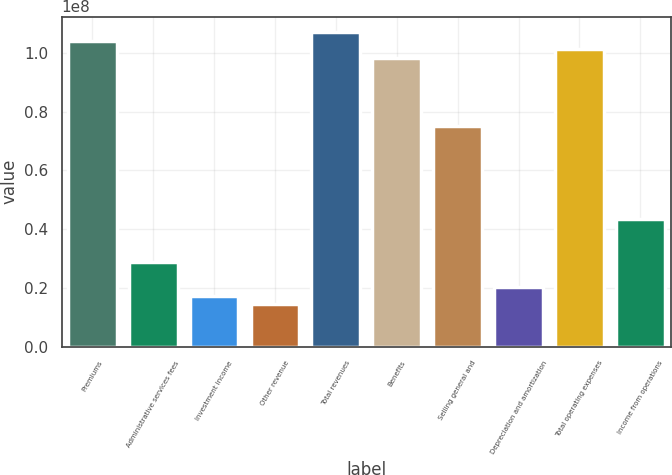Convert chart to OTSL. <chart><loc_0><loc_0><loc_500><loc_500><bar_chart><fcel>Premiums<fcel>Administrative services fees<fcel>Investment income<fcel>Other revenue<fcel>Total revenues<fcel>Benefits<fcel>Selling general and<fcel>Depreciation and amortization<fcel>Total operating expenses<fcel>Income from operations<nl><fcel>1.04207e+08<fcel>2.89464e+07<fcel>1.73678e+07<fcel>1.44732e+07<fcel>1.07102e+08<fcel>9.84177e+07<fcel>7.52606e+07<fcel>2.02625e+07<fcel>1.01312e+08<fcel>4.34196e+07<nl></chart> 